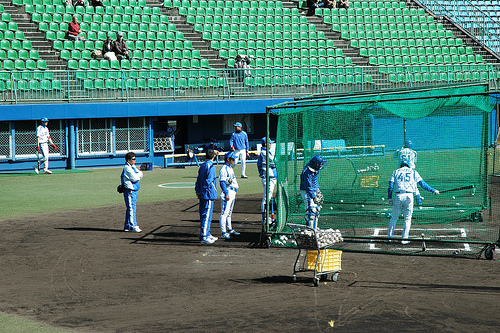<image>
Can you confirm if the kid is in the cage? Yes. The kid is contained within or inside the cage, showing a containment relationship. 